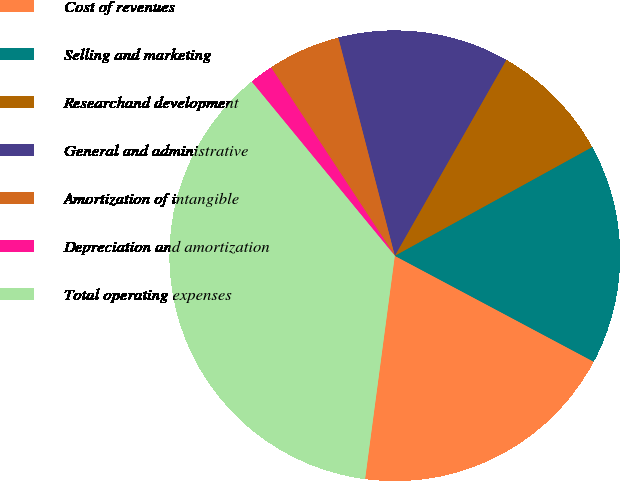Convert chart to OTSL. <chart><loc_0><loc_0><loc_500><loc_500><pie_chart><fcel>Cost of revenues<fcel>Selling and marketing<fcel>Researchand development<fcel>General and administrative<fcel>Amortization of intangible<fcel>Depreciation and amortization<fcel>Total operating expenses<nl><fcel>19.32%<fcel>15.8%<fcel>8.75%<fcel>12.27%<fcel>5.22%<fcel>1.7%<fcel>36.94%<nl></chart> 